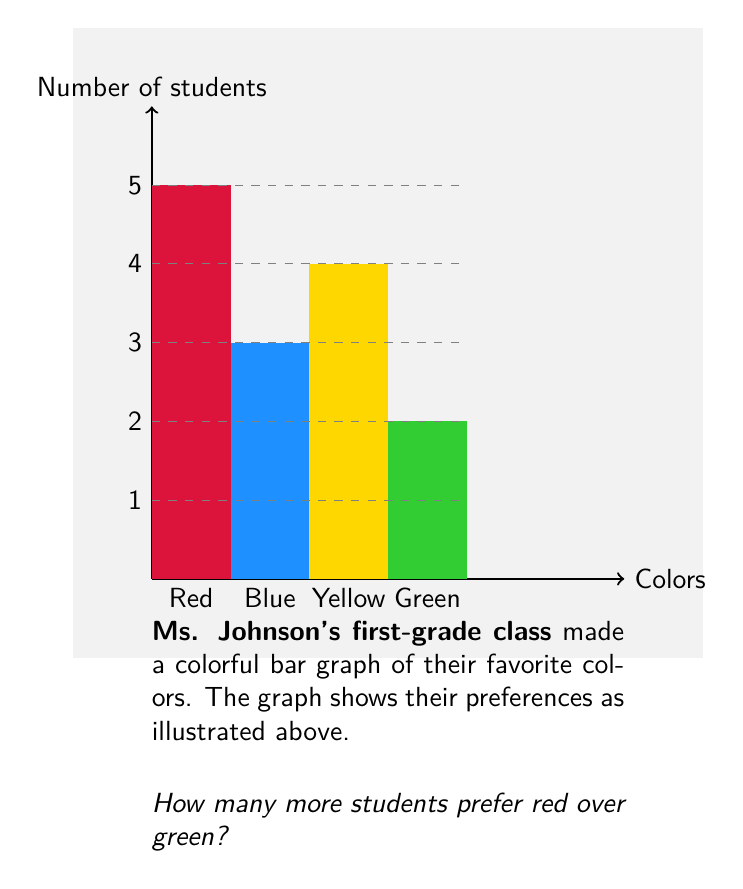Teach me how to tackle this problem. Let's count the bars in our colorful graph step by step:

1. Find the red bar:
   - The red bar goes up to 5 students

2. Find the green bar:
   - The green bar goes up to 2 students

3. Calculate the difference:
   - To find how many more students prefer red, we subtract:
   $$ \text{Red students} - \text{Green students} = 5 - 2 = 3 $$

So, 3 more students prefer red over green!
Answer: 3 students 